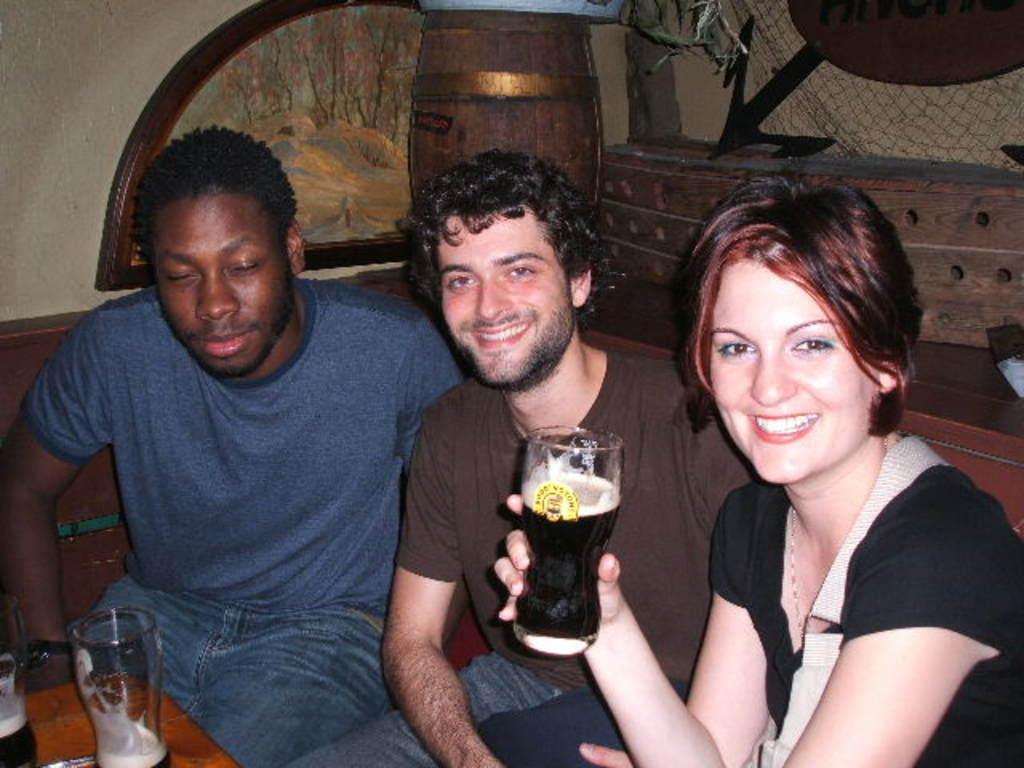Can you describe this image briefly? In this picture we can see two men sand one woman sitting on chair where woman is holding glass in her hand with drink in it and they are smiling and in front of them we have two glasses on table and in background we can see wall. 